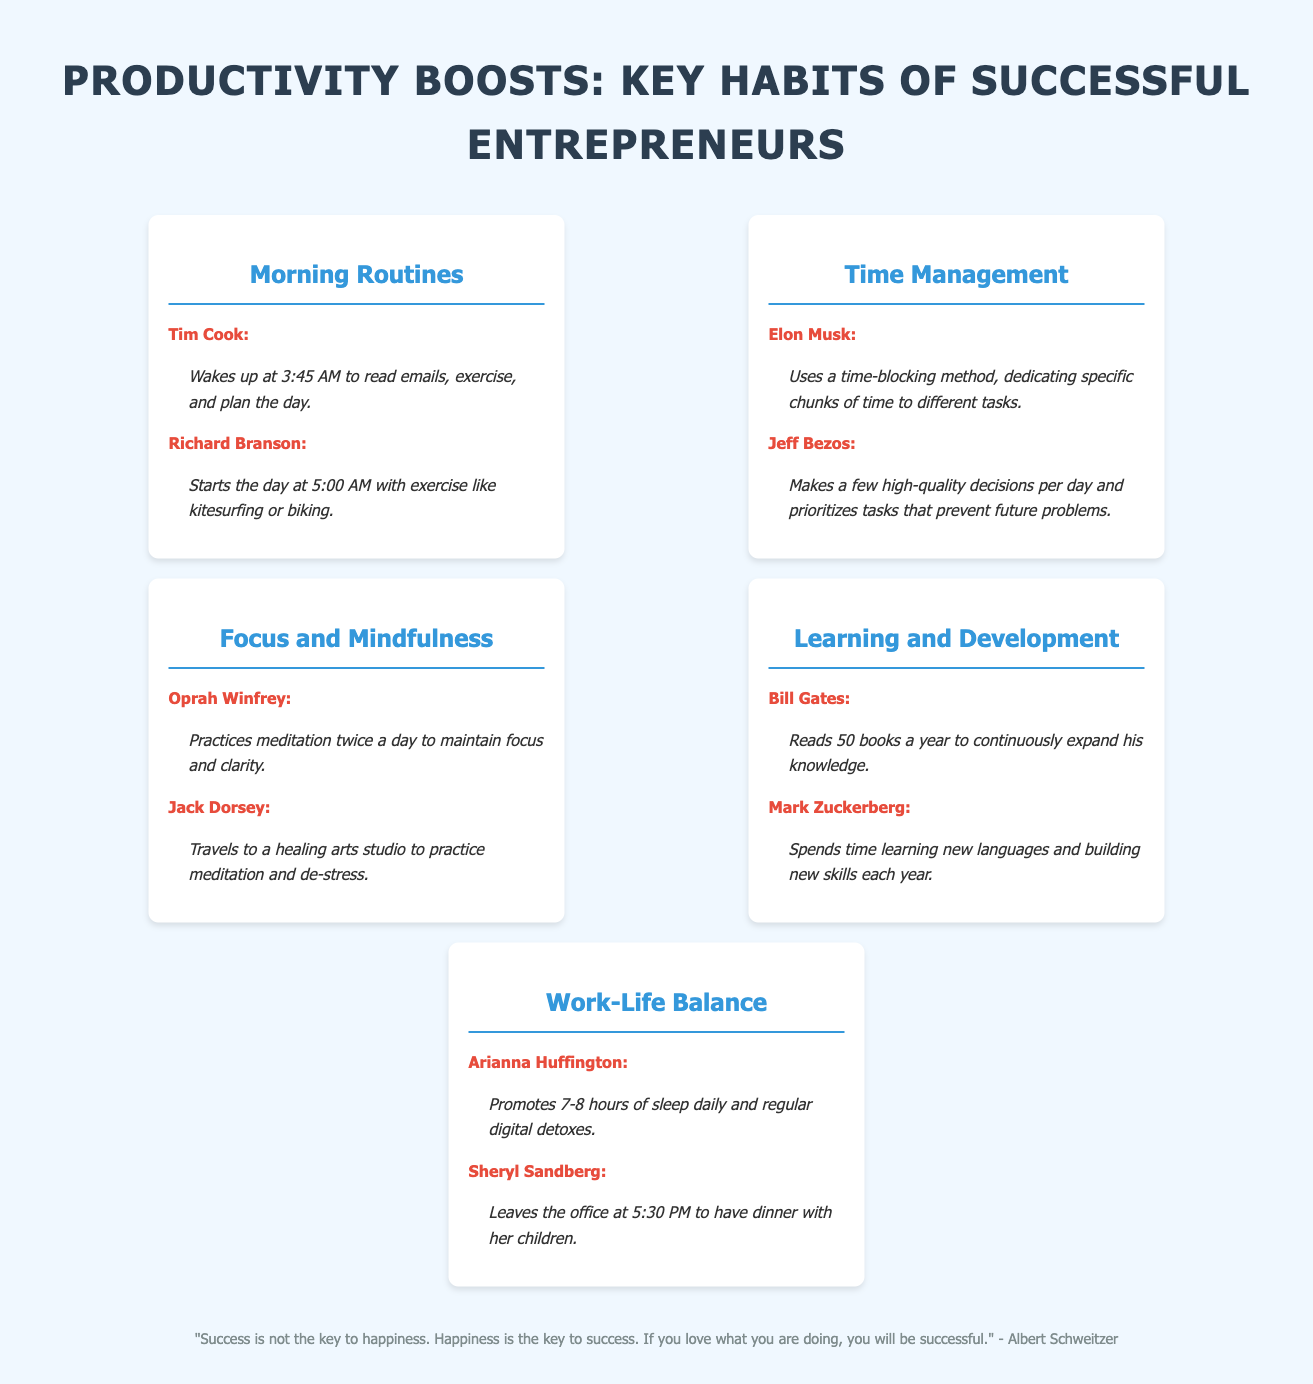What time does Tim Cook wake up? Tim Cook wakes up at 3:45 AM according to the document.
Answer: 3:45 AM What habit does Oprah Winfrey practice? Oprah Winfrey practices meditation twice a day to maintain focus and clarity.
Answer: Meditation Who reads 50 books a year? According to the document, Bill Gates reads 50 books a year to continuously expand his knowledge.
Answer: Bill Gates What is Richard Branson's morning activity? Richard Branson starts the day with exercise like kitesurfing or biking.
Answer: Exercise How many hours of sleep does Arianna Huffington promote? Arianna Huffington promotes 7-8 hours of sleep daily.
Answer: 7-8 hours What is a method used by Elon Musk for time management? Elon Musk uses a time-blocking method, dedicating specific chunks of time to different tasks.
Answer: Time-blocking What does Sheryl Sandberg prioritize in her schedule? Sheryl Sandberg leaves the office at 5:30 PM to have dinner with her children.
Answer: Dinner with her children How often does Jack Dorsey meditate? The document indicates that Jack Dorsey travels to a healing arts studio to practice meditation and de-stress.
Answer: Regularly What quote is included in the document? The document includes a quote by Albert Schweitzer about happiness being the key to success.
Answer: "Success is not the key to happiness. Happiness is the key to success." 